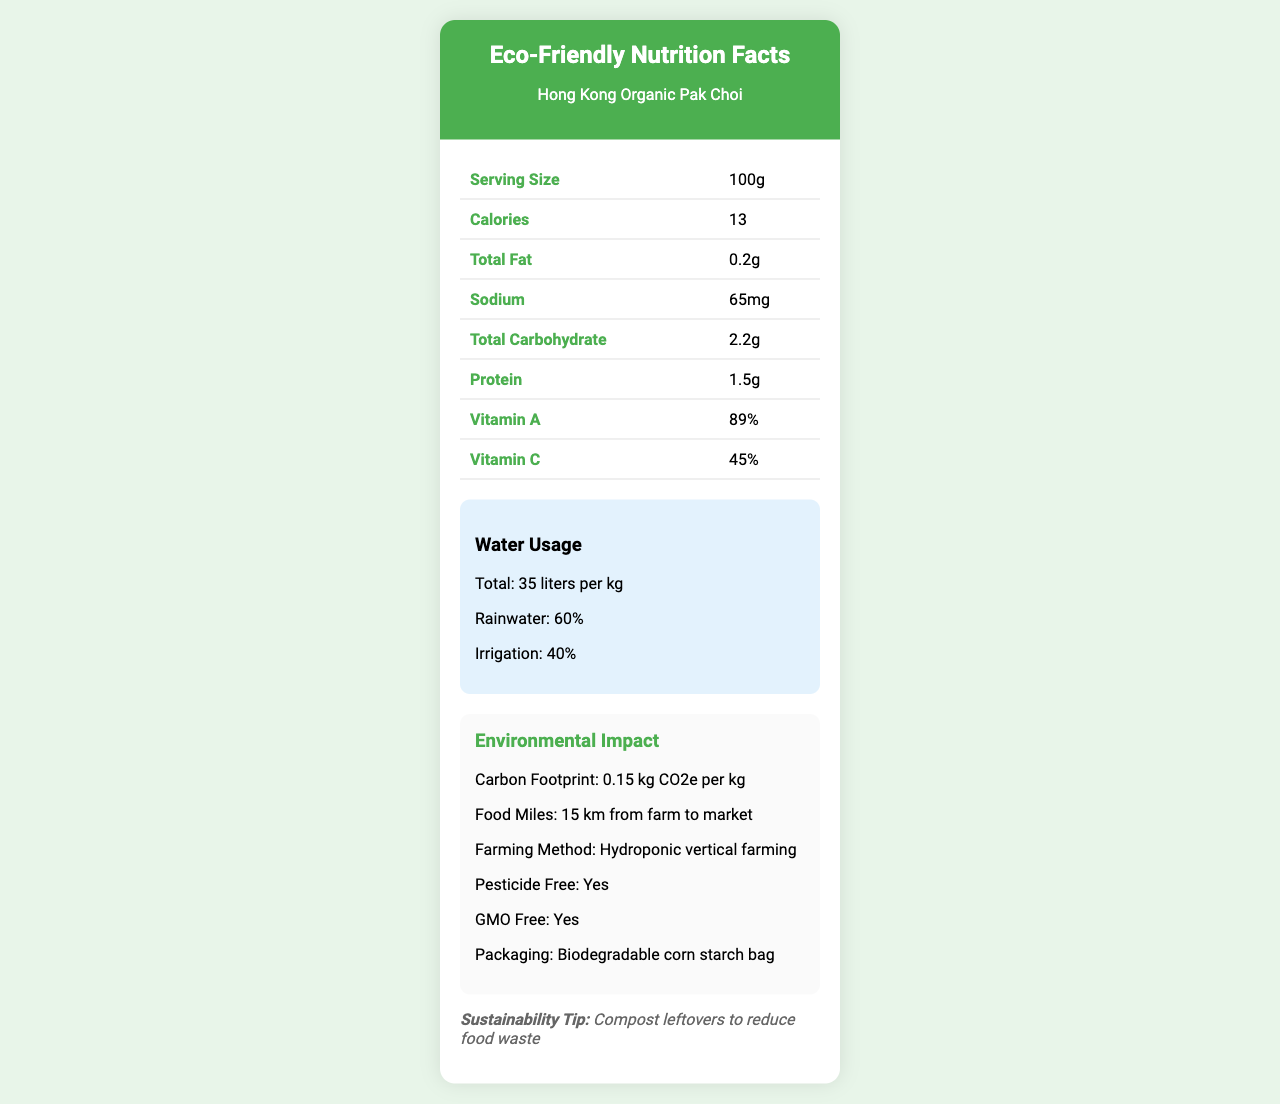What is the serving size of Hong Kong Organic Pak Choi? The serving size is listed as 100g in the document.
Answer: 100g What is the total fat content per serving? The document specifies that the total fat content per serving is 0.2g.
Answer: 0.2g How many calories are there per serving? The document states that there are 13 calories per serving.
Answer: 13 What percentage of the water used in the production of Hong Kong Organic Pak Choi comes from rainwater? The document indicates that 60% of the water used comes from rainwater.
Answer: 60% What is the sodium content per serving? According to the document, the sodium content per serving is 65mg.
Answer: 65mg What is the farming method used for Hong Kong Organic Pak Choi? A. Organic soil farming B. Hydroponic vertical farming C. Aquaponics D. Conventional farming The document states that the farming method used is hydroponic vertical farming.
Answer: B Which of the following is NOT an environmental impact mentioned in the document? A. Carbon footprint B. Water contamination C. Food miles D. Packaging The document does not mention water contamination as an environmental impact.
Answer: B Is the packaging for Hong Kong Organic Pak Choi biodegradable? (Yes/No) The document specifies that the packaging is a biodegradable corn starch bag.
Answer: Yes Summarize the main idea of the document. The document highlights key nutritional facts, water usage, environmental impacts, and sustainability tips for Hong Kong Organic Pak Choi, emphasizing its low environmental footprint and local farming benefits.
Answer: The document provides nutritional information and environmental impact details for Hong Kong Organic Pak Choi, including serving size, calorie content, water usage in production, carbon footprint, and sustainable farming practices. What farming certifications does Hong Kong Organic Pak Choi have? The document mentions that the product is certified by the Hong Kong Organic Resource Centre (HKORC).
Answer: Hong Kong Organic Resource Centre (HKORC) What is the potassium content per serving? The potassium content per serving is listed as 631mg in the document.
Answer: 631mg How far does the product travel from farm to market? The document states that the food miles from farm to market are 15 km.
Answer: 15 km Which element is most abundant in the Pak Choi's nutritional profile? A. Vitamin A B. Vitamin C C. Calcium D. Iron The document shows that Vitamin A is 89%, which is the highest percentage listed.
Answer: A Does the document specify how much water is used for irrigation? The document states that 40% of the water used comes from irrigation.
Answer: Yes Is the document clear about whether the vegetables are GMO-free? The document specifies that the vegetables are GMO-free.
Answer: Yes What is the main environmental benefit of supporting Hong Kong Organic Pak Choi according to the document? The document mentions that the main local environmental benefit is supporting Hong Kong's local agriculture and reducing reliance on imports.
Answer: Supports Hong Kong's local agriculture and reduces reliance on imports What recipe suggestion does the document provide for Hong Kong Organic Pak Choi? The document suggests a recipe of stir-fry with garlic and ginger.
Answer: Stir-fry with garlic and ginger How many servings per container are there? The document specifies that there are 2 servings per container.
Answer: 2 What percentage of calcium is provided per serving? The document states that each serving provides 10% of the daily value for calcium.
Answer: 10% Is there any information on the exact farm location of Hong Kong Organic Pak Choi? The document mentions that the farm location is in the New Territories, Hong Kong.
Answer: New Territories, Hong Kong Which vitamin provides the second highest percentage of daily value per serving? A. Vitamin A B. Vitamin C C. Calcium D. Iron Vitamin C provides 45% of the daily value, which is the second highest after Vitamin A.
Answer: B How many grams of dietary fiber are in each serving? The document lists the dietary fiber content as 1g per serving.
Answer: 1g What is the total water usage per kilogram in liters? The document specifies that the total water usage is 35 liters per kg.
Answer: 35 liters per kg What is the environmental certification listed for Hong Kong Organic Pak Choi? The document mentions that the product is certified by the Hong Kong Organic Resource Centre (HKORC).
Answer: Hong Kong Organic Resource Centre (HKORC) What are the storage instructions for Hong Kong Organic Pak Choi? The document specifies that the product should be refrigerated at 1-4°C for up to 5 days.
Answer: Refrigerate at 1-4°C for up to 5 days Can the exact method of irrigation be determined from the document? The document specifies the percentage of water from irrigation but does not detail the exact irrigation method used.
Answer: Not enough information 